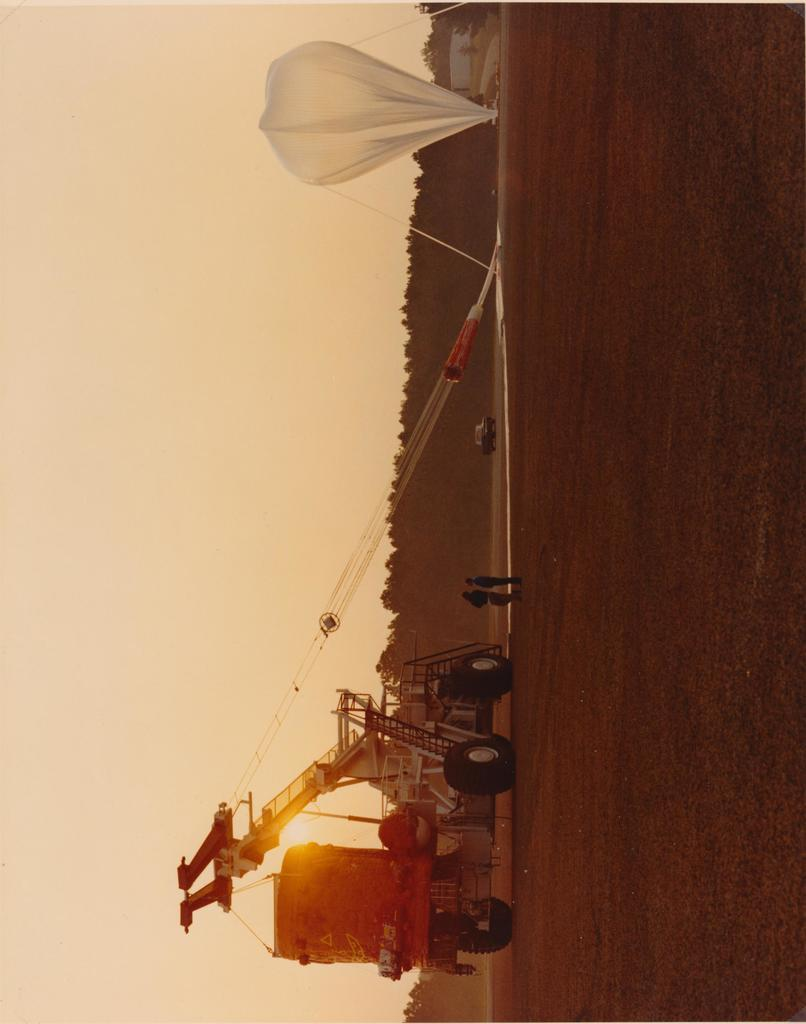What type of landscape is depicted in the image? There is a vast land in the image. What is the object falling from the sky in the image? There is a parachute in the image. What mode of transportation can be seen in the image? There is a vehicle in the image. What type of vegetation is visible in the background of the image? Trees are present in the background of the image. What part of the sky is visible in the image? The sky is visible on the left side of the image. Where is the faucet located in the image? There is no faucet present in the image. What type of property is being sold in the image? There is no property being sold in the image. 